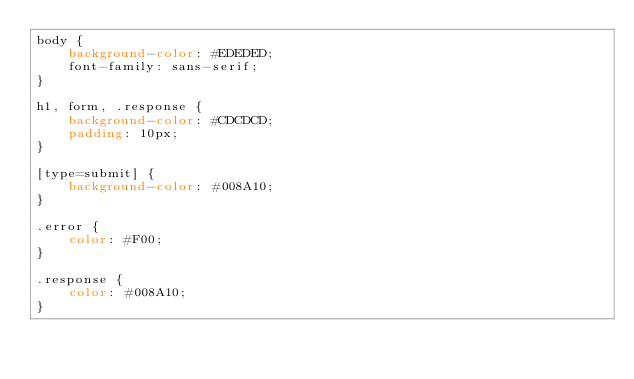Convert code to text. <code><loc_0><loc_0><loc_500><loc_500><_CSS_>body {
    background-color: #EDEDED;
    font-family: sans-serif;
}

h1, form, .response {
    background-color: #CDCDCD;
    padding: 10px;
}

[type=submit] {
    background-color: #008A10;
}

.error {
    color: #F00;
}

.response {
    color: #008A10;
}</code> 